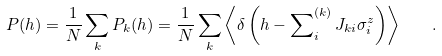<formula> <loc_0><loc_0><loc_500><loc_500>P ( h ) = \frac { 1 } { N } \sum _ { k } P _ { k } ( h ) = \frac { 1 } { N } \sum _ { k } \left \langle \delta \left ( h - \sum _ { i } \nolimits ^ { ( k ) } J _ { k i } \sigma ^ { z } _ { i } \right ) \right \rangle \quad .</formula> 